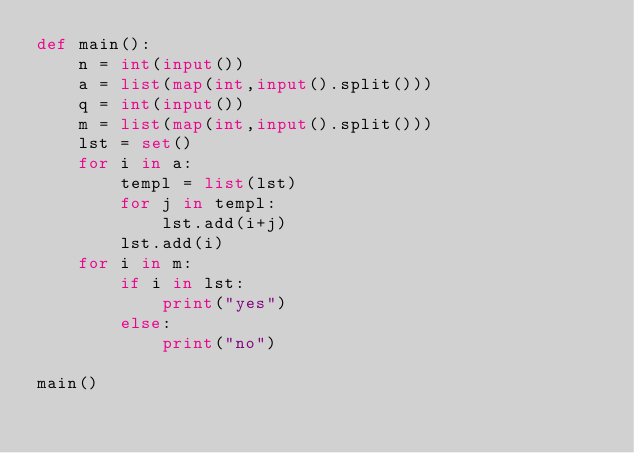Convert code to text. <code><loc_0><loc_0><loc_500><loc_500><_Python_>def main():
	n = int(input())
	a = list(map(int,input().split()))
	q = int(input())
	m = list(map(int,input().split()))
	lst = set()
	for i in a:
		templ = list(lst)
		for j in templ:
			lst.add(i+j)
		lst.add(i)
	for i in m:
		if i in lst:
			print("yes")
		else:
			print("no")

main()
</code> 